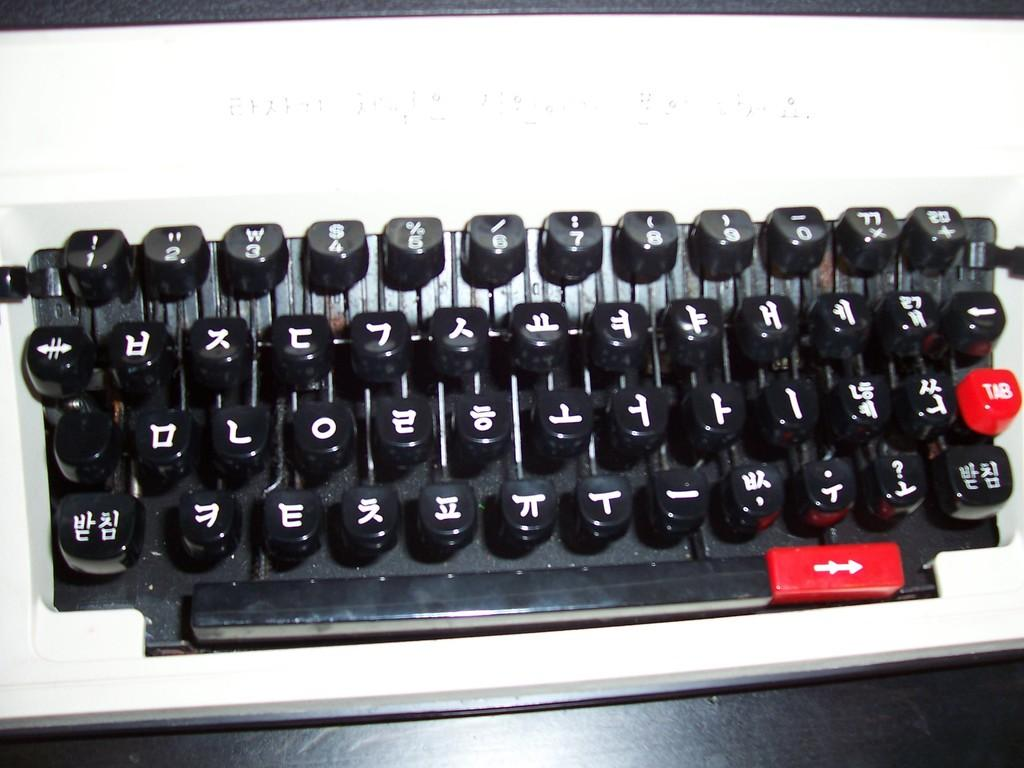What is the main object in the image? There is a keyboard of a typewriter in the image. Can you describe the keyboard in more detail? The keyboard consists of individual keys that are used for typing on the typewriter. What is the purpose of the typewriter keyboard? The keyboard is used for inputting text and characters into the typewriter. What type of jelly can be seen dripping from the typewriter keys in the image? There is no jelly present in the image; it features a keyboard of a typewriter. How does the sack contribute to the functionality of the typewriter in the image? There is no sack present in the image, and therefore it cannot contribute to the functionality of the typewriter. 